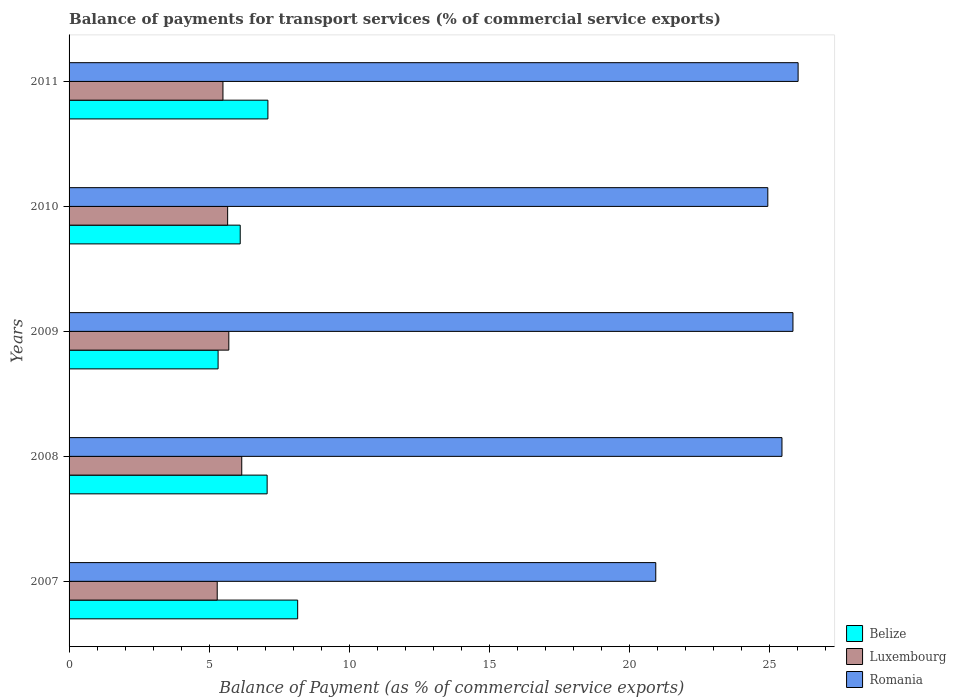How many different coloured bars are there?
Give a very brief answer. 3. How many bars are there on the 2nd tick from the bottom?
Offer a terse response. 3. In how many cases, is the number of bars for a given year not equal to the number of legend labels?
Keep it short and to the point. 0. What is the balance of payments for transport services in Luxembourg in 2010?
Offer a very short reply. 5.66. Across all years, what is the maximum balance of payments for transport services in Luxembourg?
Provide a short and direct response. 6.16. Across all years, what is the minimum balance of payments for transport services in Romania?
Ensure brevity in your answer.  20.94. In which year was the balance of payments for transport services in Luxembourg maximum?
Keep it short and to the point. 2008. In which year was the balance of payments for transport services in Belize minimum?
Provide a succinct answer. 2009. What is the total balance of payments for transport services in Luxembourg in the graph?
Offer a very short reply. 28.3. What is the difference between the balance of payments for transport services in Luxembourg in 2008 and that in 2010?
Your answer should be very brief. 0.5. What is the difference between the balance of payments for transport services in Luxembourg in 2008 and the balance of payments for transport services in Belize in 2007?
Your answer should be very brief. -2. What is the average balance of payments for transport services in Belize per year?
Give a very brief answer. 6.75. In the year 2007, what is the difference between the balance of payments for transport services in Belize and balance of payments for transport services in Romania?
Provide a short and direct response. -12.78. What is the ratio of the balance of payments for transport services in Luxembourg in 2007 to that in 2008?
Give a very brief answer. 0.86. Is the balance of payments for transport services in Luxembourg in 2007 less than that in 2008?
Your response must be concise. Yes. Is the difference between the balance of payments for transport services in Belize in 2008 and 2009 greater than the difference between the balance of payments for transport services in Romania in 2008 and 2009?
Your response must be concise. Yes. What is the difference between the highest and the second highest balance of payments for transport services in Romania?
Keep it short and to the point. 0.18. What is the difference between the highest and the lowest balance of payments for transport services in Romania?
Your answer should be compact. 5.08. Is the sum of the balance of payments for transport services in Belize in 2008 and 2010 greater than the maximum balance of payments for transport services in Romania across all years?
Your response must be concise. No. What does the 1st bar from the top in 2007 represents?
Ensure brevity in your answer.  Romania. What does the 1st bar from the bottom in 2007 represents?
Make the answer very short. Belize. How many bars are there?
Offer a very short reply. 15. Are all the bars in the graph horizontal?
Your answer should be very brief. Yes. How many years are there in the graph?
Your response must be concise. 5. What is the difference between two consecutive major ticks on the X-axis?
Ensure brevity in your answer.  5. What is the title of the graph?
Your answer should be compact. Balance of payments for transport services (% of commercial service exports). Does "Kenya" appear as one of the legend labels in the graph?
Keep it short and to the point. No. What is the label or title of the X-axis?
Keep it short and to the point. Balance of Payment (as % of commercial service exports). What is the Balance of Payment (as % of commercial service exports) of Belize in 2007?
Give a very brief answer. 8.16. What is the Balance of Payment (as % of commercial service exports) of Luxembourg in 2007?
Provide a succinct answer. 5.29. What is the Balance of Payment (as % of commercial service exports) in Romania in 2007?
Your answer should be compact. 20.94. What is the Balance of Payment (as % of commercial service exports) in Belize in 2008?
Your response must be concise. 7.07. What is the Balance of Payment (as % of commercial service exports) of Luxembourg in 2008?
Offer a very short reply. 6.16. What is the Balance of Payment (as % of commercial service exports) in Romania in 2008?
Ensure brevity in your answer.  25.44. What is the Balance of Payment (as % of commercial service exports) of Belize in 2009?
Give a very brief answer. 5.32. What is the Balance of Payment (as % of commercial service exports) in Luxembourg in 2009?
Keep it short and to the point. 5.7. What is the Balance of Payment (as % of commercial service exports) in Romania in 2009?
Give a very brief answer. 25.83. What is the Balance of Payment (as % of commercial service exports) of Belize in 2010?
Provide a short and direct response. 6.11. What is the Balance of Payment (as % of commercial service exports) in Luxembourg in 2010?
Your response must be concise. 5.66. What is the Balance of Payment (as % of commercial service exports) in Romania in 2010?
Give a very brief answer. 24.94. What is the Balance of Payment (as % of commercial service exports) in Belize in 2011?
Your answer should be very brief. 7.1. What is the Balance of Payment (as % of commercial service exports) of Luxembourg in 2011?
Offer a terse response. 5.49. What is the Balance of Payment (as % of commercial service exports) in Romania in 2011?
Provide a short and direct response. 26.02. Across all years, what is the maximum Balance of Payment (as % of commercial service exports) in Belize?
Provide a short and direct response. 8.16. Across all years, what is the maximum Balance of Payment (as % of commercial service exports) in Luxembourg?
Give a very brief answer. 6.16. Across all years, what is the maximum Balance of Payment (as % of commercial service exports) of Romania?
Offer a very short reply. 26.02. Across all years, what is the minimum Balance of Payment (as % of commercial service exports) of Belize?
Provide a short and direct response. 5.32. Across all years, what is the minimum Balance of Payment (as % of commercial service exports) in Luxembourg?
Your response must be concise. 5.29. Across all years, what is the minimum Balance of Payment (as % of commercial service exports) in Romania?
Make the answer very short. 20.94. What is the total Balance of Payment (as % of commercial service exports) in Belize in the graph?
Provide a short and direct response. 33.75. What is the total Balance of Payment (as % of commercial service exports) of Luxembourg in the graph?
Offer a terse response. 28.3. What is the total Balance of Payment (as % of commercial service exports) of Romania in the graph?
Provide a succinct answer. 123.17. What is the difference between the Balance of Payment (as % of commercial service exports) in Belize in 2007 and that in 2008?
Your answer should be very brief. 1.09. What is the difference between the Balance of Payment (as % of commercial service exports) of Luxembourg in 2007 and that in 2008?
Offer a terse response. -0.88. What is the difference between the Balance of Payment (as % of commercial service exports) in Romania in 2007 and that in 2008?
Your answer should be very brief. -4.5. What is the difference between the Balance of Payment (as % of commercial service exports) in Belize in 2007 and that in 2009?
Your response must be concise. 2.84. What is the difference between the Balance of Payment (as % of commercial service exports) in Luxembourg in 2007 and that in 2009?
Keep it short and to the point. -0.41. What is the difference between the Balance of Payment (as % of commercial service exports) of Romania in 2007 and that in 2009?
Offer a very short reply. -4.9. What is the difference between the Balance of Payment (as % of commercial service exports) of Belize in 2007 and that in 2010?
Your response must be concise. 2.05. What is the difference between the Balance of Payment (as % of commercial service exports) of Luxembourg in 2007 and that in 2010?
Offer a very short reply. -0.37. What is the difference between the Balance of Payment (as % of commercial service exports) in Romania in 2007 and that in 2010?
Offer a very short reply. -4. What is the difference between the Balance of Payment (as % of commercial service exports) of Belize in 2007 and that in 2011?
Provide a succinct answer. 1.06. What is the difference between the Balance of Payment (as % of commercial service exports) in Luxembourg in 2007 and that in 2011?
Your answer should be compact. -0.2. What is the difference between the Balance of Payment (as % of commercial service exports) of Romania in 2007 and that in 2011?
Offer a terse response. -5.08. What is the difference between the Balance of Payment (as % of commercial service exports) in Belize in 2008 and that in 2009?
Your answer should be compact. 1.75. What is the difference between the Balance of Payment (as % of commercial service exports) of Luxembourg in 2008 and that in 2009?
Your answer should be very brief. 0.46. What is the difference between the Balance of Payment (as % of commercial service exports) in Romania in 2008 and that in 2009?
Your answer should be compact. -0.39. What is the difference between the Balance of Payment (as % of commercial service exports) in Belize in 2008 and that in 2010?
Provide a succinct answer. 0.96. What is the difference between the Balance of Payment (as % of commercial service exports) in Luxembourg in 2008 and that in 2010?
Provide a short and direct response. 0.5. What is the difference between the Balance of Payment (as % of commercial service exports) in Romania in 2008 and that in 2010?
Keep it short and to the point. 0.51. What is the difference between the Balance of Payment (as % of commercial service exports) in Belize in 2008 and that in 2011?
Provide a short and direct response. -0.03. What is the difference between the Balance of Payment (as % of commercial service exports) in Luxembourg in 2008 and that in 2011?
Make the answer very short. 0.67. What is the difference between the Balance of Payment (as % of commercial service exports) in Romania in 2008 and that in 2011?
Offer a very short reply. -0.58. What is the difference between the Balance of Payment (as % of commercial service exports) in Belize in 2009 and that in 2010?
Give a very brief answer. -0.79. What is the difference between the Balance of Payment (as % of commercial service exports) in Luxembourg in 2009 and that in 2010?
Keep it short and to the point. 0.04. What is the difference between the Balance of Payment (as % of commercial service exports) in Romania in 2009 and that in 2010?
Offer a very short reply. 0.9. What is the difference between the Balance of Payment (as % of commercial service exports) of Belize in 2009 and that in 2011?
Provide a succinct answer. -1.78. What is the difference between the Balance of Payment (as % of commercial service exports) in Luxembourg in 2009 and that in 2011?
Offer a very short reply. 0.21. What is the difference between the Balance of Payment (as % of commercial service exports) of Romania in 2009 and that in 2011?
Keep it short and to the point. -0.18. What is the difference between the Balance of Payment (as % of commercial service exports) in Belize in 2010 and that in 2011?
Your answer should be compact. -0.99. What is the difference between the Balance of Payment (as % of commercial service exports) in Luxembourg in 2010 and that in 2011?
Offer a very short reply. 0.17. What is the difference between the Balance of Payment (as % of commercial service exports) of Romania in 2010 and that in 2011?
Your response must be concise. -1.08. What is the difference between the Balance of Payment (as % of commercial service exports) in Belize in 2007 and the Balance of Payment (as % of commercial service exports) in Luxembourg in 2008?
Offer a terse response. 2. What is the difference between the Balance of Payment (as % of commercial service exports) in Belize in 2007 and the Balance of Payment (as % of commercial service exports) in Romania in 2008?
Your answer should be very brief. -17.28. What is the difference between the Balance of Payment (as % of commercial service exports) in Luxembourg in 2007 and the Balance of Payment (as % of commercial service exports) in Romania in 2008?
Offer a very short reply. -20.16. What is the difference between the Balance of Payment (as % of commercial service exports) of Belize in 2007 and the Balance of Payment (as % of commercial service exports) of Luxembourg in 2009?
Ensure brevity in your answer.  2.46. What is the difference between the Balance of Payment (as % of commercial service exports) of Belize in 2007 and the Balance of Payment (as % of commercial service exports) of Romania in 2009?
Offer a very short reply. -17.68. What is the difference between the Balance of Payment (as % of commercial service exports) in Luxembourg in 2007 and the Balance of Payment (as % of commercial service exports) in Romania in 2009?
Give a very brief answer. -20.55. What is the difference between the Balance of Payment (as % of commercial service exports) of Belize in 2007 and the Balance of Payment (as % of commercial service exports) of Luxembourg in 2010?
Offer a very short reply. 2.5. What is the difference between the Balance of Payment (as % of commercial service exports) of Belize in 2007 and the Balance of Payment (as % of commercial service exports) of Romania in 2010?
Your answer should be compact. -16.78. What is the difference between the Balance of Payment (as % of commercial service exports) in Luxembourg in 2007 and the Balance of Payment (as % of commercial service exports) in Romania in 2010?
Offer a very short reply. -19.65. What is the difference between the Balance of Payment (as % of commercial service exports) of Belize in 2007 and the Balance of Payment (as % of commercial service exports) of Luxembourg in 2011?
Offer a very short reply. 2.67. What is the difference between the Balance of Payment (as % of commercial service exports) in Belize in 2007 and the Balance of Payment (as % of commercial service exports) in Romania in 2011?
Provide a succinct answer. -17.86. What is the difference between the Balance of Payment (as % of commercial service exports) in Luxembourg in 2007 and the Balance of Payment (as % of commercial service exports) in Romania in 2011?
Your answer should be very brief. -20.73. What is the difference between the Balance of Payment (as % of commercial service exports) in Belize in 2008 and the Balance of Payment (as % of commercial service exports) in Luxembourg in 2009?
Your response must be concise. 1.37. What is the difference between the Balance of Payment (as % of commercial service exports) in Belize in 2008 and the Balance of Payment (as % of commercial service exports) in Romania in 2009?
Provide a short and direct response. -18.77. What is the difference between the Balance of Payment (as % of commercial service exports) of Luxembourg in 2008 and the Balance of Payment (as % of commercial service exports) of Romania in 2009?
Give a very brief answer. -19.67. What is the difference between the Balance of Payment (as % of commercial service exports) in Belize in 2008 and the Balance of Payment (as % of commercial service exports) in Luxembourg in 2010?
Make the answer very short. 1.41. What is the difference between the Balance of Payment (as % of commercial service exports) of Belize in 2008 and the Balance of Payment (as % of commercial service exports) of Romania in 2010?
Offer a very short reply. -17.87. What is the difference between the Balance of Payment (as % of commercial service exports) of Luxembourg in 2008 and the Balance of Payment (as % of commercial service exports) of Romania in 2010?
Provide a succinct answer. -18.77. What is the difference between the Balance of Payment (as % of commercial service exports) of Belize in 2008 and the Balance of Payment (as % of commercial service exports) of Luxembourg in 2011?
Offer a terse response. 1.58. What is the difference between the Balance of Payment (as % of commercial service exports) of Belize in 2008 and the Balance of Payment (as % of commercial service exports) of Romania in 2011?
Your response must be concise. -18.95. What is the difference between the Balance of Payment (as % of commercial service exports) of Luxembourg in 2008 and the Balance of Payment (as % of commercial service exports) of Romania in 2011?
Provide a short and direct response. -19.86. What is the difference between the Balance of Payment (as % of commercial service exports) of Belize in 2009 and the Balance of Payment (as % of commercial service exports) of Luxembourg in 2010?
Provide a short and direct response. -0.34. What is the difference between the Balance of Payment (as % of commercial service exports) of Belize in 2009 and the Balance of Payment (as % of commercial service exports) of Romania in 2010?
Provide a succinct answer. -19.62. What is the difference between the Balance of Payment (as % of commercial service exports) in Luxembourg in 2009 and the Balance of Payment (as % of commercial service exports) in Romania in 2010?
Your answer should be compact. -19.24. What is the difference between the Balance of Payment (as % of commercial service exports) in Belize in 2009 and the Balance of Payment (as % of commercial service exports) in Luxembourg in 2011?
Your response must be concise. -0.17. What is the difference between the Balance of Payment (as % of commercial service exports) of Belize in 2009 and the Balance of Payment (as % of commercial service exports) of Romania in 2011?
Provide a succinct answer. -20.7. What is the difference between the Balance of Payment (as % of commercial service exports) in Luxembourg in 2009 and the Balance of Payment (as % of commercial service exports) in Romania in 2011?
Give a very brief answer. -20.32. What is the difference between the Balance of Payment (as % of commercial service exports) of Belize in 2010 and the Balance of Payment (as % of commercial service exports) of Luxembourg in 2011?
Give a very brief answer. 0.62. What is the difference between the Balance of Payment (as % of commercial service exports) in Belize in 2010 and the Balance of Payment (as % of commercial service exports) in Romania in 2011?
Keep it short and to the point. -19.91. What is the difference between the Balance of Payment (as % of commercial service exports) of Luxembourg in 2010 and the Balance of Payment (as % of commercial service exports) of Romania in 2011?
Your answer should be compact. -20.36. What is the average Balance of Payment (as % of commercial service exports) of Belize per year?
Give a very brief answer. 6.75. What is the average Balance of Payment (as % of commercial service exports) of Luxembourg per year?
Ensure brevity in your answer.  5.66. What is the average Balance of Payment (as % of commercial service exports) of Romania per year?
Keep it short and to the point. 24.63. In the year 2007, what is the difference between the Balance of Payment (as % of commercial service exports) in Belize and Balance of Payment (as % of commercial service exports) in Luxembourg?
Your answer should be compact. 2.87. In the year 2007, what is the difference between the Balance of Payment (as % of commercial service exports) of Belize and Balance of Payment (as % of commercial service exports) of Romania?
Your answer should be compact. -12.78. In the year 2007, what is the difference between the Balance of Payment (as % of commercial service exports) in Luxembourg and Balance of Payment (as % of commercial service exports) in Romania?
Ensure brevity in your answer.  -15.65. In the year 2008, what is the difference between the Balance of Payment (as % of commercial service exports) in Belize and Balance of Payment (as % of commercial service exports) in Luxembourg?
Keep it short and to the point. 0.91. In the year 2008, what is the difference between the Balance of Payment (as % of commercial service exports) in Belize and Balance of Payment (as % of commercial service exports) in Romania?
Give a very brief answer. -18.37. In the year 2008, what is the difference between the Balance of Payment (as % of commercial service exports) of Luxembourg and Balance of Payment (as % of commercial service exports) of Romania?
Your answer should be very brief. -19.28. In the year 2009, what is the difference between the Balance of Payment (as % of commercial service exports) of Belize and Balance of Payment (as % of commercial service exports) of Luxembourg?
Provide a succinct answer. -0.38. In the year 2009, what is the difference between the Balance of Payment (as % of commercial service exports) in Belize and Balance of Payment (as % of commercial service exports) in Romania?
Offer a terse response. -20.52. In the year 2009, what is the difference between the Balance of Payment (as % of commercial service exports) of Luxembourg and Balance of Payment (as % of commercial service exports) of Romania?
Ensure brevity in your answer.  -20.13. In the year 2010, what is the difference between the Balance of Payment (as % of commercial service exports) in Belize and Balance of Payment (as % of commercial service exports) in Luxembourg?
Your answer should be compact. 0.45. In the year 2010, what is the difference between the Balance of Payment (as % of commercial service exports) of Belize and Balance of Payment (as % of commercial service exports) of Romania?
Offer a terse response. -18.83. In the year 2010, what is the difference between the Balance of Payment (as % of commercial service exports) of Luxembourg and Balance of Payment (as % of commercial service exports) of Romania?
Your answer should be very brief. -19.28. In the year 2011, what is the difference between the Balance of Payment (as % of commercial service exports) of Belize and Balance of Payment (as % of commercial service exports) of Luxembourg?
Give a very brief answer. 1.6. In the year 2011, what is the difference between the Balance of Payment (as % of commercial service exports) of Belize and Balance of Payment (as % of commercial service exports) of Romania?
Give a very brief answer. -18.92. In the year 2011, what is the difference between the Balance of Payment (as % of commercial service exports) of Luxembourg and Balance of Payment (as % of commercial service exports) of Romania?
Offer a very short reply. -20.53. What is the ratio of the Balance of Payment (as % of commercial service exports) in Belize in 2007 to that in 2008?
Provide a succinct answer. 1.15. What is the ratio of the Balance of Payment (as % of commercial service exports) of Luxembourg in 2007 to that in 2008?
Provide a short and direct response. 0.86. What is the ratio of the Balance of Payment (as % of commercial service exports) of Romania in 2007 to that in 2008?
Offer a terse response. 0.82. What is the ratio of the Balance of Payment (as % of commercial service exports) in Belize in 2007 to that in 2009?
Your response must be concise. 1.53. What is the ratio of the Balance of Payment (as % of commercial service exports) of Luxembourg in 2007 to that in 2009?
Offer a terse response. 0.93. What is the ratio of the Balance of Payment (as % of commercial service exports) of Romania in 2007 to that in 2009?
Provide a succinct answer. 0.81. What is the ratio of the Balance of Payment (as % of commercial service exports) in Belize in 2007 to that in 2010?
Your response must be concise. 1.34. What is the ratio of the Balance of Payment (as % of commercial service exports) in Luxembourg in 2007 to that in 2010?
Give a very brief answer. 0.93. What is the ratio of the Balance of Payment (as % of commercial service exports) in Romania in 2007 to that in 2010?
Offer a terse response. 0.84. What is the ratio of the Balance of Payment (as % of commercial service exports) of Belize in 2007 to that in 2011?
Provide a short and direct response. 1.15. What is the ratio of the Balance of Payment (as % of commercial service exports) in Luxembourg in 2007 to that in 2011?
Make the answer very short. 0.96. What is the ratio of the Balance of Payment (as % of commercial service exports) in Romania in 2007 to that in 2011?
Ensure brevity in your answer.  0.8. What is the ratio of the Balance of Payment (as % of commercial service exports) in Belize in 2008 to that in 2009?
Give a very brief answer. 1.33. What is the ratio of the Balance of Payment (as % of commercial service exports) of Luxembourg in 2008 to that in 2009?
Make the answer very short. 1.08. What is the ratio of the Balance of Payment (as % of commercial service exports) of Belize in 2008 to that in 2010?
Provide a succinct answer. 1.16. What is the ratio of the Balance of Payment (as % of commercial service exports) of Luxembourg in 2008 to that in 2010?
Offer a very short reply. 1.09. What is the ratio of the Balance of Payment (as % of commercial service exports) of Romania in 2008 to that in 2010?
Offer a terse response. 1.02. What is the ratio of the Balance of Payment (as % of commercial service exports) in Luxembourg in 2008 to that in 2011?
Offer a very short reply. 1.12. What is the ratio of the Balance of Payment (as % of commercial service exports) of Romania in 2008 to that in 2011?
Ensure brevity in your answer.  0.98. What is the ratio of the Balance of Payment (as % of commercial service exports) of Belize in 2009 to that in 2010?
Make the answer very short. 0.87. What is the ratio of the Balance of Payment (as % of commercial service exports) in Luxembourg in 2009 to that in 2010?
Your answer should be very brief. 1.01. What is the ratio of the Balance of Payment (as % of commercial service exports) of Romania in 2009 to that in 2010?
Your answer should be very brief. 1.04. What is the ratio of the Balance of Payment (as % of commercial service exports) in Belize in 2009 to that in 2011?
Your answer should be compact. 0.75. What is the ratio of the Balance of Payment (as % of commercial service exports) in Luxembourg in 2009 to that in 2011?
Offer a very short reply. 1.04. What is the ratio of the Balance of Payment (as % of commercial service exports) in Belize in 2010 to that in 2011?
Make the answer very short. 0.86. What is the ratio of the Balance of Payment (as % of commercial service exports) of Luxembourg in 2010 to that in 2011?
Ensure brevity in your answer.  1.03. What is the ratio of the Balance of Payment (as % of commercial service exports) of Romania in 2010 to that in 2011?
Your response must be concise. 0.96. What is the difference between the highest and the second highest Balance of Payment (as % of commercial service exports) in Belize?
Offer a terse response. 1.06. What is the difference between the highest and the second highest Balance of Payment (as % of commercial service exports) of Luxembourg?
Give a very brief answer. 0.46. What is the difference between the highest and the second highest Balance of Payment (as % of commercial service exports) in Romania?
Provide a short and direct response. 0.18. What is the difference between the highest and the lowest Balance of Payment (as % of commercial service exports) in Belize?
Your response must be concise. 2.84. What is the difference between the highest and the lowest Balance of Payment (as % of commercial service exports) in Luxembourg?
Offer a very short reply. 0.88. What is the difference between the highest and the lowest Balance of Payment (as % of commercial service exports) of Romania?
Your answer should be compact. 5.08. 